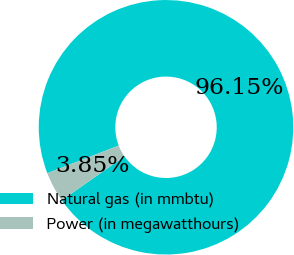<chart> <loc_0><loc_0><loc_500><loc_500><pie_chart><fcel>Natural gas (in mmbtu)<fcel>Power (in megawatthours)<nl><fcel>96.15%<fcel>3.85%<nl></chart> 